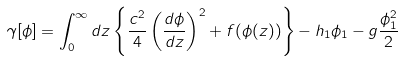Convert formula to latex. <formula><loc_0><loc_0><loc_500><loc_500>\gamma [ \phi ] = \int _ { 0 } ^ { \infty } d z \left \{ \frac { c ^ { 2 } } { 4 } \left ( \frac { d \phi } { d z } \right ) ^ { 2 } + f ( \phi ( z ) ) \right \} - h _ { 1 } \phi _ { 1 } - g \frac { \phi _ { 1 } ^ { 2 } } { 2 }</formula> 